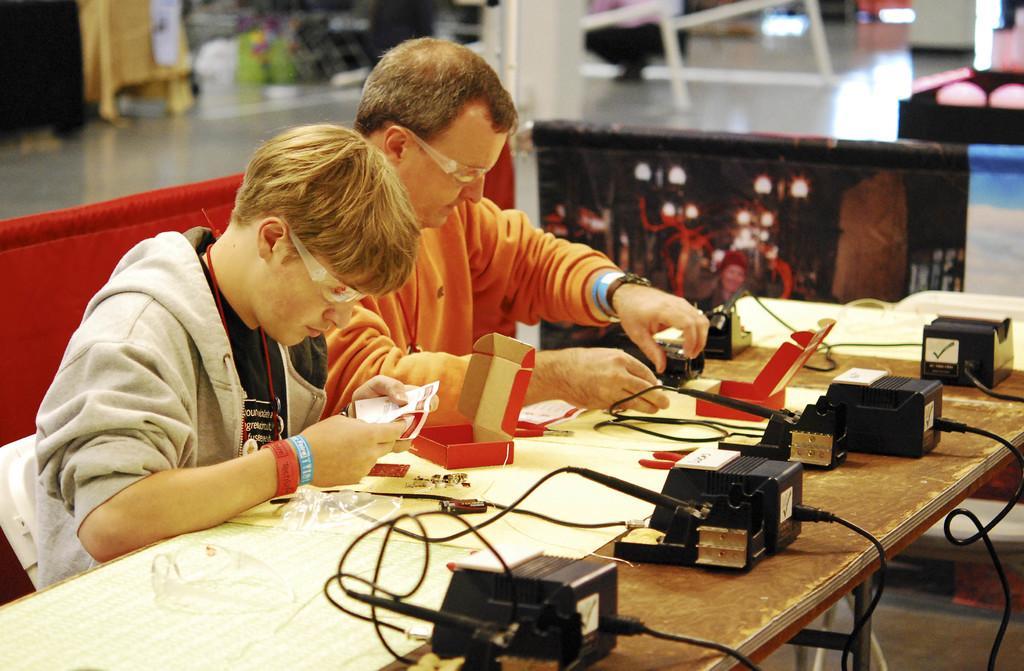Describe this image in one or two sentences. Background portion of the picture is blur. We can see the objects and the floor. In this picture we can see the men wearing goggles and its seems like they are doing an experiment. On a table we can see the devices connected with the wires, few objects and boxes. We can also see the objects. 